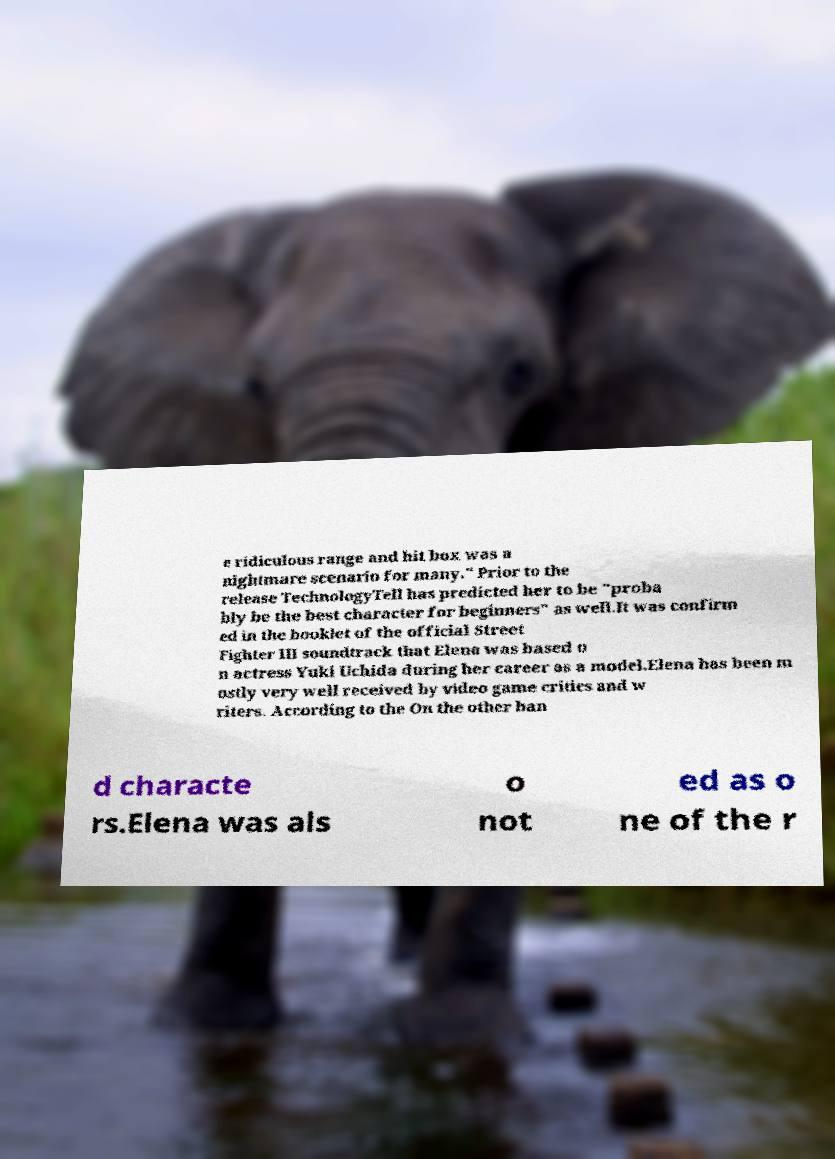There's text embedded in this image that I need extracted. Can you transcribe it verbatim? e ridiculous range and hit box was a nightmare scenario for many." Prior to the release TechnologyTell has predicted her to be "proba bly be the best character for beginners" as well.It was confirm ed in the booklet of the official Street Fighter III soundtrack that Elena was based o n actress Yuki Uchida during her career as a model.Elena has been m ostly very well received by video game critics and w riters. According to the On the other han d characte rs.Elena was als o not ed as o ne of the r 